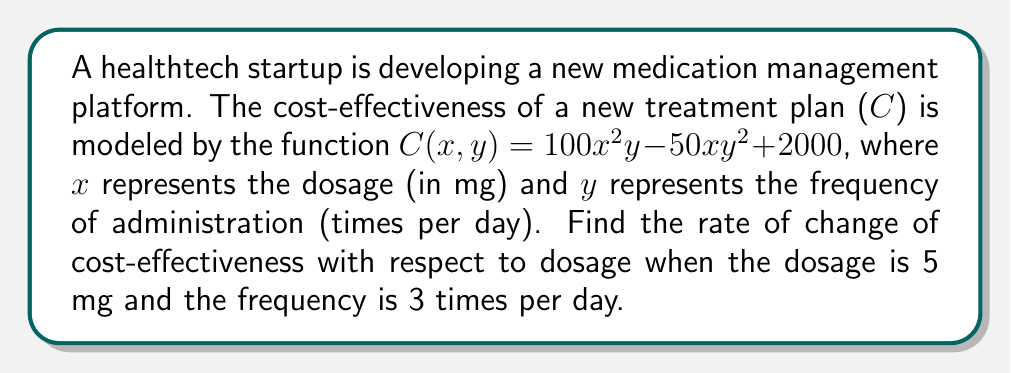Provide a solution to this math problem. To find the rate of change of cost-effectiveness with respect to dosage, we need to calculate the partial derivative of C with respect to x and then evaluate it at the given point.

Step 1: Calculate $\frac{\partial C}{\partial x}$
$$\frac{\partial C}{\partial x} = \frac{\partial}{\partial x}(100x^2y - 50xy^2 + 2000)$$
$$\frac{\partial C}{\partial x} = 200xy - 50y^2$$

Step 2: Evaluate $\frac{\partial C}{\partial x}$ at x = 5 and y = 3
$$\frac{\partial C}{\partial x}(5,3) = 200(5)(3) - 50(3^2)$$
$$\frac{\partial C}{\partial x}(5,3) = 3000 - 450$$
$$\frac{\partial C}{\partial x}(5,3) = 2550$$

Therefore, the rate of change of cost-effectiveness with respect to dosage when the dosage is 5 mg and the frequency is 3 times per day is 2550 units per mg.
Answer: 2550 units/mg 